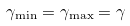Convert formula to latex. <formula><loc_0><loc_0><loc_500><loc_500>\gamma _ { \min } = \gamma _ { \max } = \gamma</formula> 